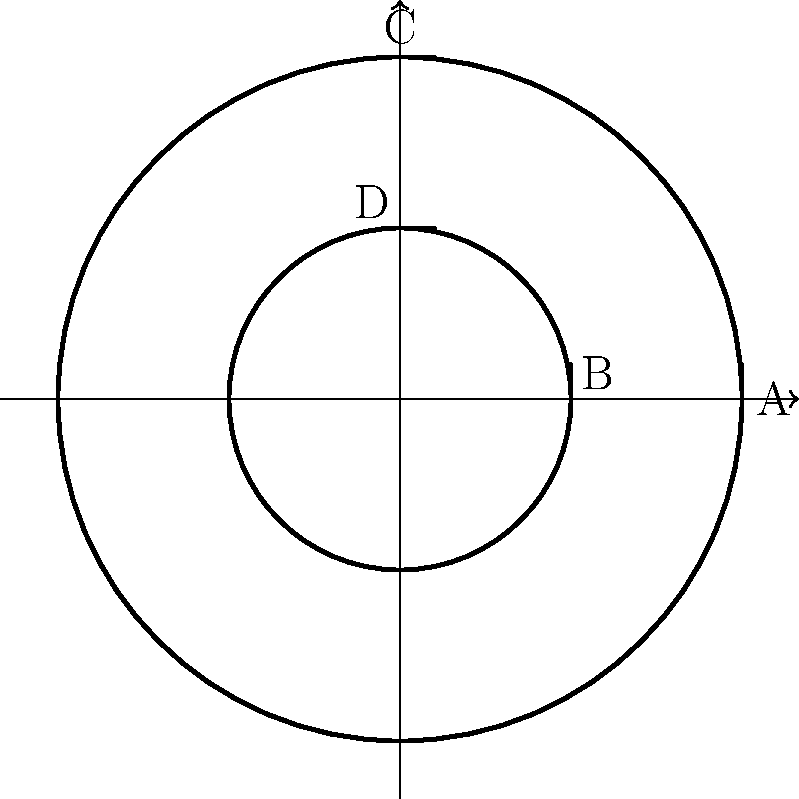Look at the wheelchair wheel diagram. Which two circles are congruent to each other? Let's approach this step-by-step:

1. In the diagram, we see two circles: a larger outer circle and a smaller inner circle.

2. To determine if circles are congruent, we need to compare their sizes (radii).

3. The outer circle has a radius that extends from the center to point A.

4. The inner circle has a radius that extends from the center to point B.

5. We can see that the distance from the center to B is exactly half of the distance from the center to A.

6. This means the inner circle is smaller than the outer circle.

7. For circles to be congruent, they must have the same size (radius).

8. In this diagram, there are no two circles that have the same size.

Therefore, there are no congruent circles in this wheelchair wheel diagram.
Answer: None 